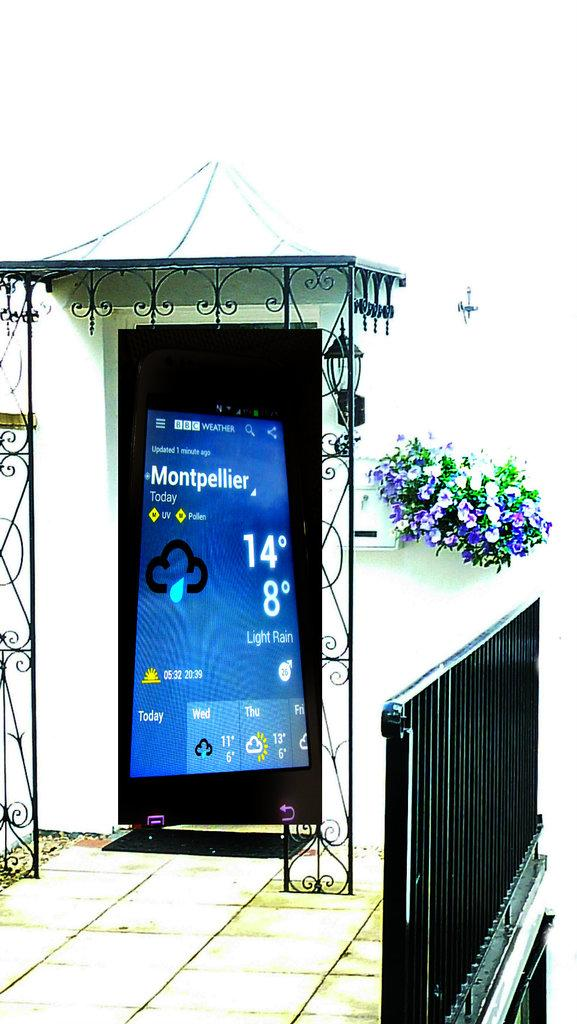Provide a one-sentence caption for the provided image. A screenshot of Montpellier's current weather is superimposed over the front door of a house. 